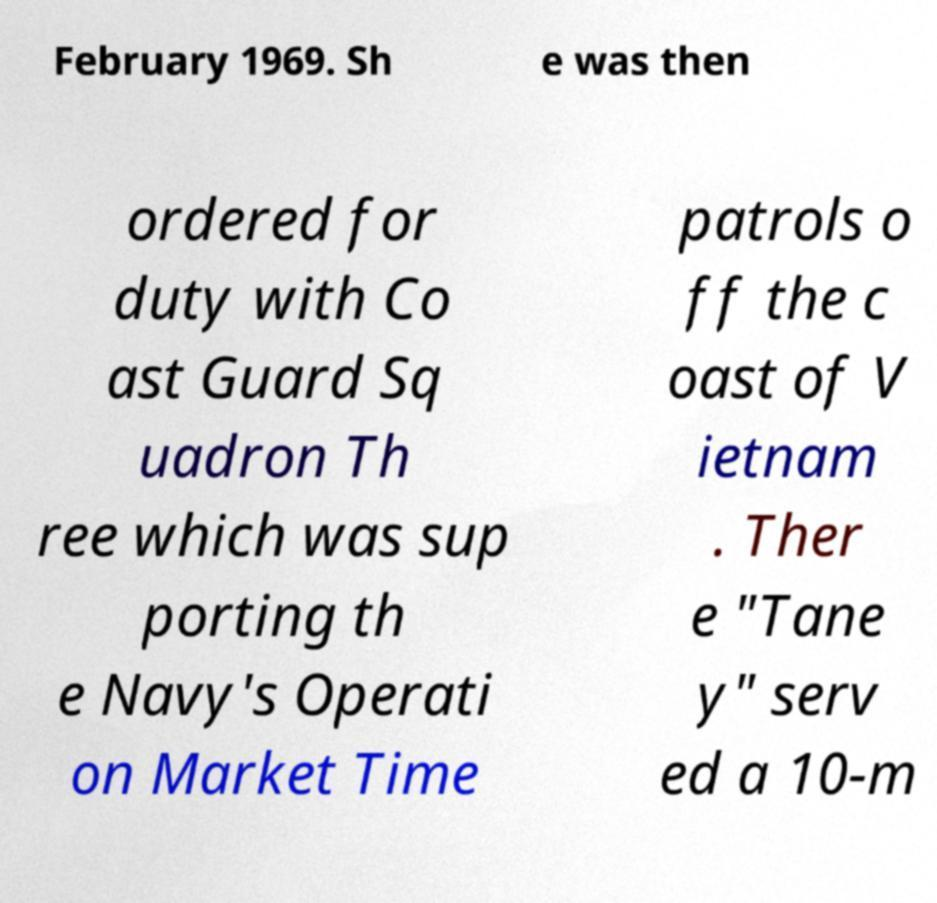What messages or text are displayed in this image? I need them in a readable, typed format. February 1969. Sh e was then ordered for duty with Co ast Guard Sq uadron Th ree which was sup porting th e Navy's Operati on Market Time patrols o ff the c oast of V ietnam . Ther e "Tane y" serv ed a 10-m 